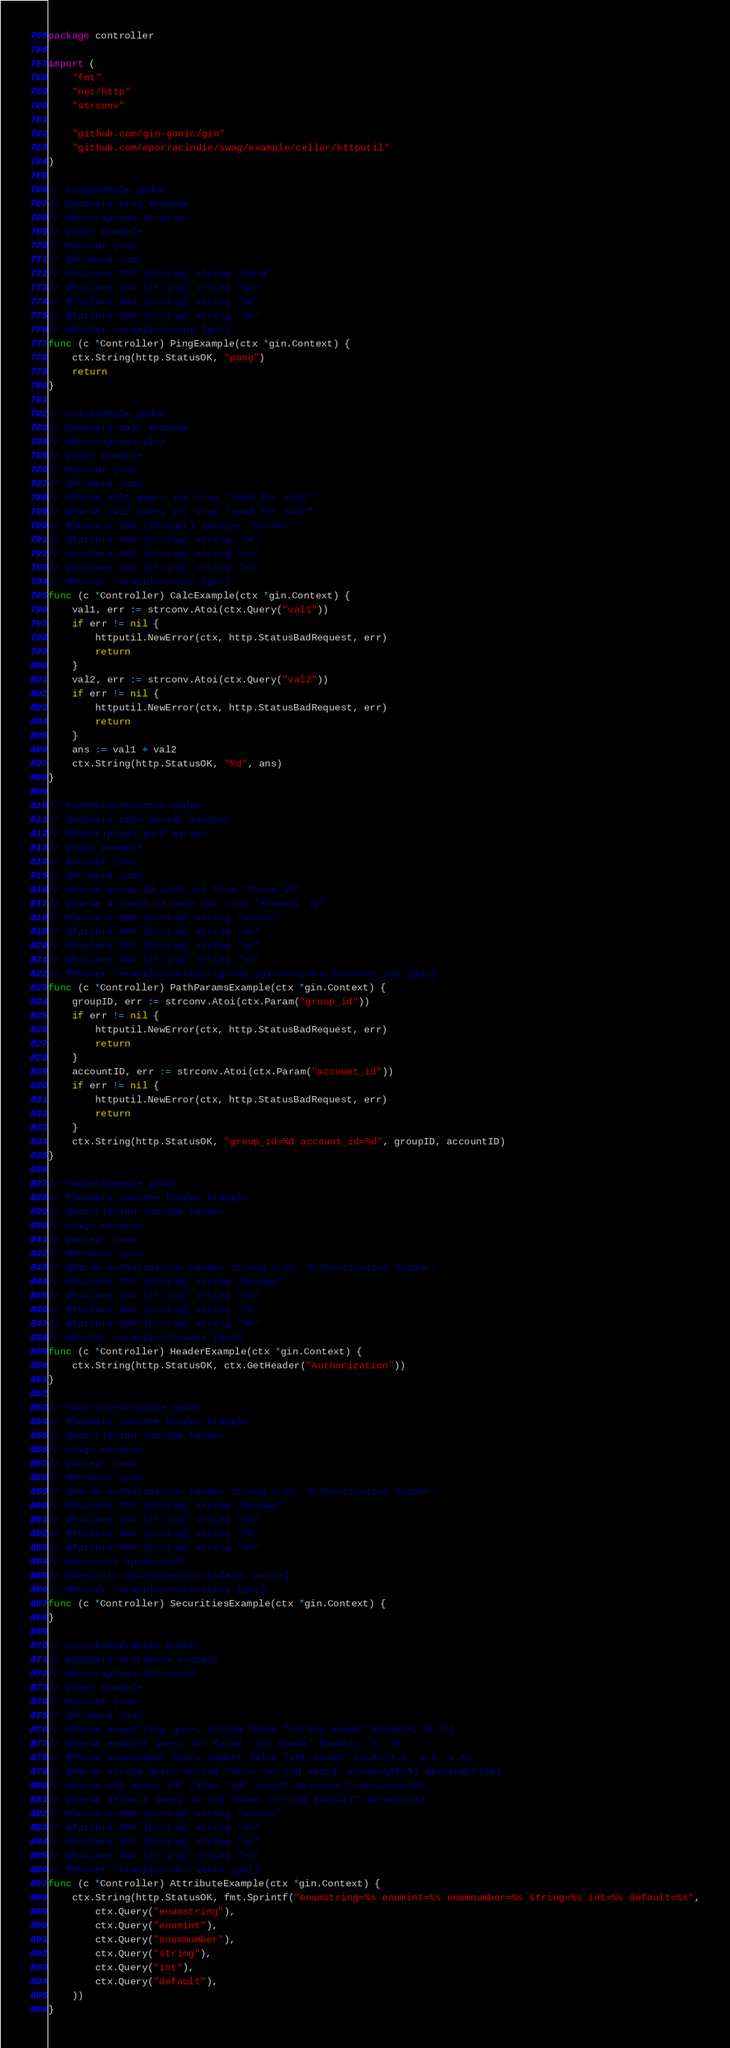Convert code to text. <code><loc_0><loc_0><loc_500><loc_500><_Go_>package controller

import (
	"fmt"
	"net/http"
	"strconv"

	"github.com/gin-gonic/gin"
	"github.com/mporracindie/swag/example/celler/httputil"
)

// PingExample godoc
// @Summary ping example
// @Description do ping
// @Tags example
// @Accept json
// @Produce json
// @Success 200 {string} string "pong"
// @Failure 400 {string} string "ok"
// @Failure 404 {string} string "ok"
// @Failure 500 {string} string "ok"
// @Router /examples/ping [get]
func (c *Controller) PingExample(ctx *gin.Context) {
	ctx.String(http.StatusOK, "pong")
	return
}

// CalcExample godoc
// @Summary calc example
// @Description plus
// @Tags example
// @Accept json
// @Produce json
// @Param val1 query int true "used for calc"
// @Param val2 query int true "used for calc"
// @Success 200 {integer} integer "answer"
// @Failure 400 {string} string "ok"
// @Failure 404 {string} string "ok"
// @Failure 500 {string} string "ok"
// @Router /examples/calc [get]
func (c *Controller) CalcExample(ctx *gin.Context) {
	val1, err := strconv.Atoi(ctx.Query("val1"))
	if err != nil {
		httputil.NewError(ctx, http.StatusBadRequest, err)
		return
	}
	val2, err := strconv.Atoi(ctx.Query("val2"))
	if err != nil {
		httputil.NewError(ctx, http.StatusBadRequest, err)
		return
	}
	ans := val1 + val2
	ctx.String(http.StatusOK, "%d", ans)
}

// PathParamsExample godoc
// @Summary path params example
// @Description path params
// @Tags example
// @Accept json
// @Produce json
// @Param group_id path int true "Group ID"
// @Param account_id path int true "Account ID"
// @Success 200 {string} string "answer"
// @Failure 400 {string} string "ok"
// @Failure 404 {string} string "ok"
// @Failure 500 {string} string "ok"
// @Router /examples/groups/{group_id}/accounts/{account_id} [get]
func (c *Controller) PathParamsExample(ctx *gin.Context) {
	groupID, err := strconv.Atoi(ctx.Param("group_id"))
	if err != nil {
		httputil.NewError(ctx, http.StatusBadRequest, err)
		return
	}
	accountID, err := strconv.Atoi(ctx.Param("account_id"))
	if err != nil {
		httputil.NewError(ctx, http.StatusBadRequest, err)
		return
	}
	ctx.String(http.StatusOK, "group_id=%d account_id=%d", groupID, accountID)
}

// HeaderExample godoc
// @Summary custome header example
// @Description custome header
// @Tags example
// @Accept json
// @Produce json
// @Param Authorization header string true "Authentication header"
// @Success 200 {string} string "answer"
// @Failure 400 {string} string "ok"
// @Failure 404 {string} string "ok"
// @Failure 500 {string} string "ok"
// @Router /examples/header [get]
func (c *Controller) HeaderExample(ctx *gin.Context) {
	ctx.String(http.StatusOK, ctx.GetHeader("Authorization"))
}

// SecuritiesExample godoc
// @Summary custome header example
// @Description custome header
// @Tags example
// @Accept json
// @Produce json
// @Param Authorization header string true "Authentication header"
// @Success 200 {string} string "answer"
// @Failure 400 {string} string "ok"
// @Failure 404 {string} string "ok"
// @Failure 500 {string} string "ok"
// @Security ApiKeyAuth
// @Security OAuth2Implicit[admin, write]
// @Router /examples/securities [get]
func (c *Controller) SecuritiesExample(ctx *gin.Context) {
}

// AttributeExample godoc
// @Summary attribute example
// @Description attribute
// @Tags example
// @Accept json
// @Produce json
// @Param enumstring query string false "string enums" Enums(A, B, C)
// @Param enumint query int false "int enums" Enums(1, 2, 3)
// @Param enumnumber query number false "int enums" Enums(1.1, 1.2, 1.3)
// @Param string query string false "string valid" minlength(5) maxlength(10)
// @Param int query int false "int valid" mininum(1) maxinum(10)
// @Param default query string false "string default" default(A)
// @Success 200 {string} string "answer"
// @Failure 400 {string} string "ok"
// @Failure 404 {string} string "ok"
// @Failure 500 {string} string "ok"
// @Router /examples/attribute [get]
func (c *Controller) AttributeExample(ctx *gin.Context) {
	ctx.String(http.StatusOK, fmt.Sprintf("enumstring=%s enumint=%s enumnumber=%s string=%s int=%s default=%s",
		ctx.Query("enumstring"),
		ctx.Query("enumint"),
		ctx.Query("enumnumber"),
		ctx.Query("string"),
		ctx.Query("int"),
		ctx.Query("default"),
	))
}
</code> 